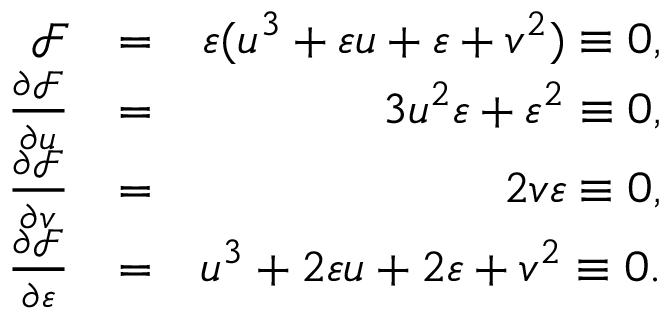Convert formula to latex. <formula><loc_0><loc_0><loc_500><loc_500>\begin{array} { r l r } { \mathcal { F } } & { = } & { \varepsilon ( u ^ { 3 } + \varepsilon u + \varepsilon + v ^ { 2 } ) \equiv 0 , } \\ { \frac { \partial \mathcal { F } } { \partial u } } & { = } & { 3 u ^ { 2 } \varepsilon + \varepsilon ^ { 2 } \equiv 0 , } \\ { \frac { \partial \mathcal { F } } { \partial v } } & { = } & { 2 v \varepsilon \equiv 0 , } \\ { \frac { \partial \mathcal { F } } { \partial \varepsilon } } & { = } & { u ^ { 3 } + 2 \varepsilon u + 2 \varepsilon + v ^ { 2 } \equiv 0 . } \end{array}</formula> 